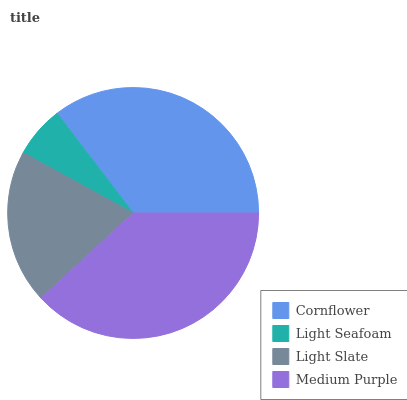Is Light Seafoam the minimum?
Answer yes or no. Yes. Is Medium Purple the maximum?
Answer yes or no. Yes. Is Light Slate the minimum?
Answer yes or no. No. Is Light Slate the maximum?
Answer yes or no. No. Is Light Slate greater than Light Seafoam?
Answer yes or no. Yes. Is Light Seafoam less than Light Slate?
Answer yes or no. Yes. Is Light Seafoam greater than Light Slate?
Answer yes or no. No. Is Light Slate less than Light Seafoam?
Answer yes or no. No. Is Cornflower the high median?
Answer yes or no. Yes. Is Light Slate the low median?
Answer yes or no. Yes. Is Medium Purple the high median?
Answer yes or no. No. Is Cornflower the low median?
Answer yes or no. No. 